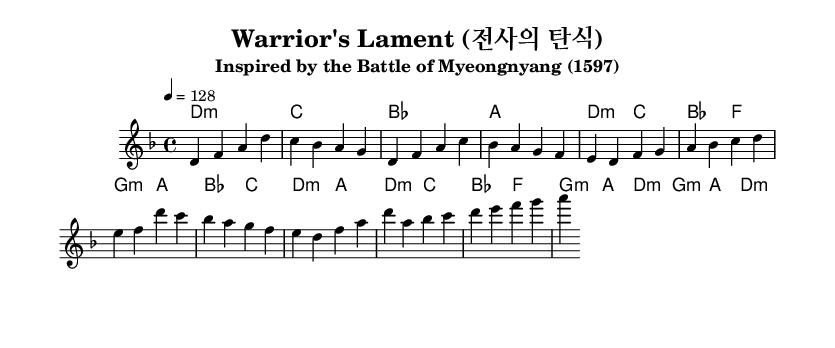What is the key signature of this music? The key signature is D minor, indicated by one flat (B flat). This can be identified by looking at the key signature area at the beginning of the score.
Answer: D minor What is the time signature of this piece? The time signature is 4/4, which is seen at the beginning of the score. This means there are four beats in each measure, and a quarter note receives one beat.
Answer: 4/4 What is the tempo marking for this composition? The tempo marking is 128 beats per minute, specified in the score. This indicates the speed at which the piece should be played.
Answer: 128 How many measures are present in the melody? The melody contains a total of 12 measures, which can be counted by observing the measures in the melodic section.
Answer: 12 What is the structure of the song? The structure consists of an intro, verse, pre-chorus, chorus, and a partial bridge. This can be inferred from the labeling in the music, showing the different sections labeled appropriately.
Answer: Intro, Verse, Pre-chorus, Chorus, Bridge Which historical event inspired this piece? The piece is inspired by the Battle of Myeongnyang, which took place in 1597. This information is noted in the subtitle of the score.
Answer: Battle of Myeongnyang What is the primary feeling conveyed by the key of D minor in this context? The key of D minor often conveys a somber or melancholic feel, aligning with the theme of lamentation suggested by the title "Warrior's Lament." This can be inferred from both musical theory and the title.
Answer: Somber 